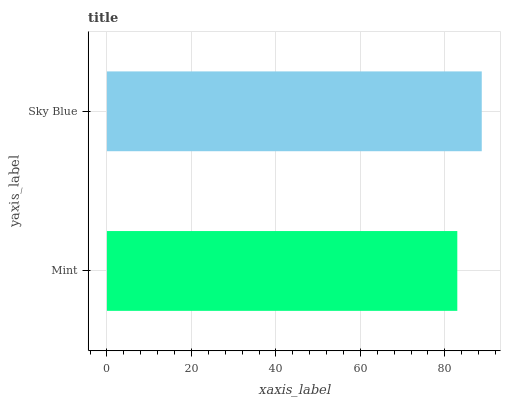Is Mint the minimum?
Answer yes or no. Yes. Is Sky Blue the maximum?
Answer yes or no. Yes. Is Sky Blue the minimum?
Answer yes or no. No. Is Sky Blue greater than Mint?
Answer yes or no. Yes. Is Mint less than Sky Blue?
Answer yes or no. Yes. Is Mint greater than Sky Blue?
Answer yes or no. No. Is Sky Blue less than Mint?
Answer yes or no. No. Is Sky Blue the high median?
Answer yes or no. Yes. Is Mint the low median?
Answer yes or no. Yes. Is Mint the high median?
Answer yes or no. No. Is Sky Blue the low median?
Answer yes or no. No. 